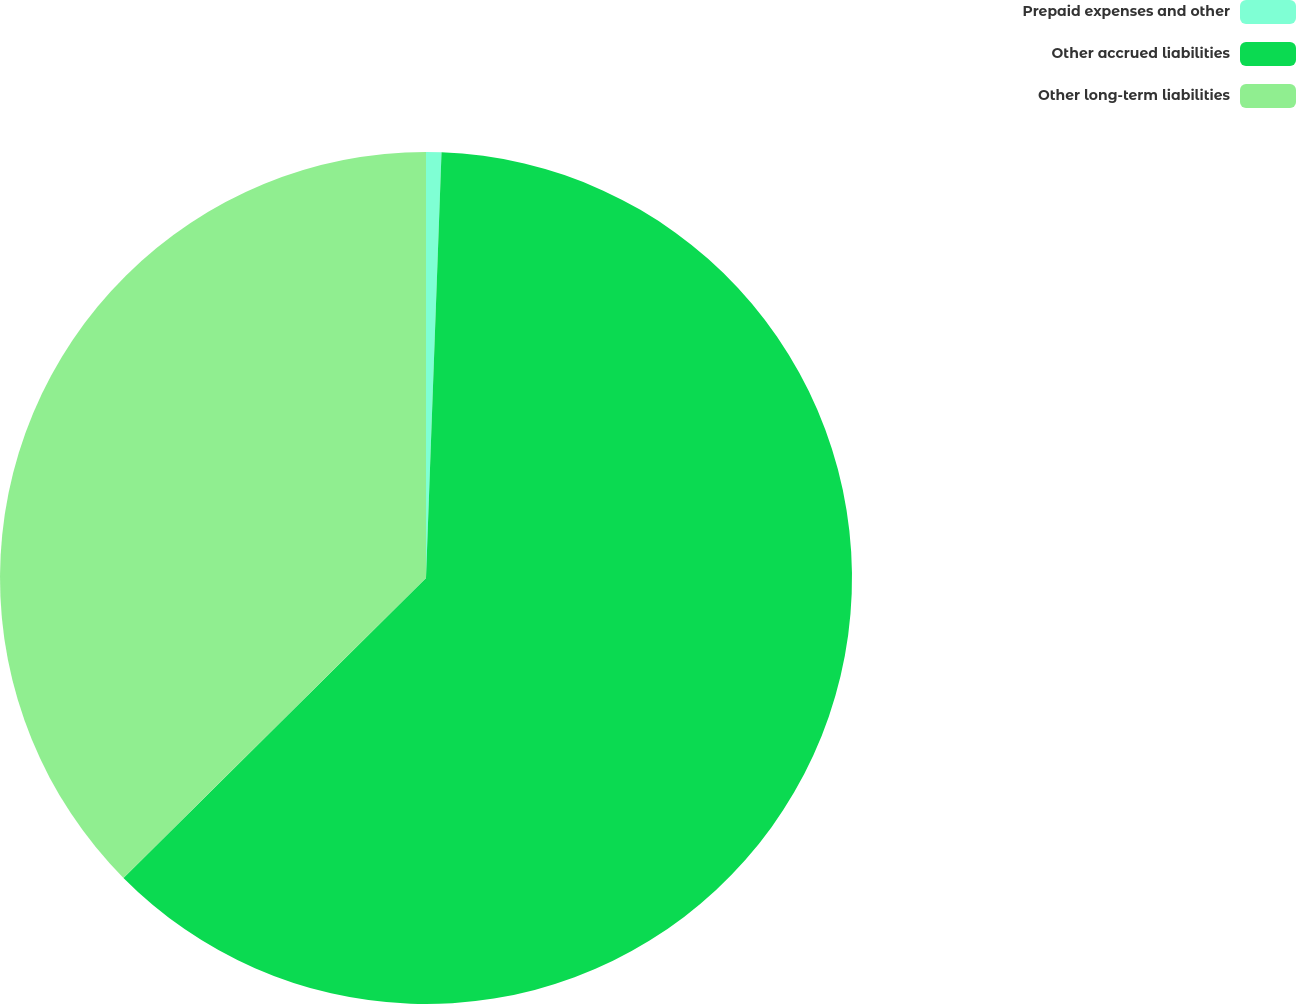Convert chart. <chart><loc_0><loc_0><loc_500><loc_500><pie_chart><fcel>Prepaid expenses and other<fcel>Other accrued liabilities<fcel>Other long-term liabilities<nl><fcel>0.58%<fcel>61.99%<fcel>37.43%<nl></chart> 